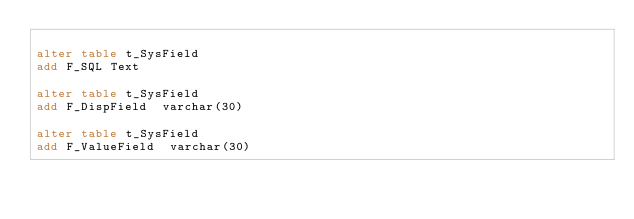<code> <loc_0><loc_0><loc_500><loc_500><_SQL_>
alter table t_SysField
add F_SQL Text

alter table t_SysField
add F_DispField  varchar(30)

alter table t_SysField
add F_ValueField  varchar(30)</code> 